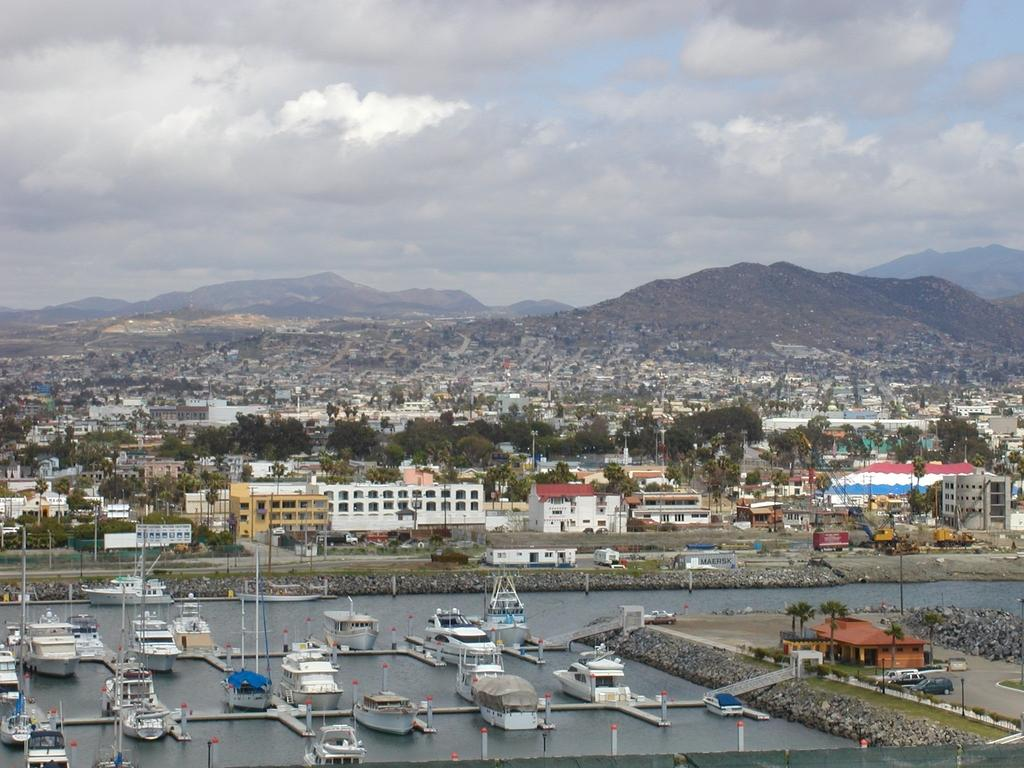What type of structures can be seen in the image? There are buildings in the image. What other natural elements are present in the image? There are trees and hills visible in the image. What can be seen in the water in the image? There are ships and boats in the water. How would you describe the sky in the image? The sky is blue and cloudy. Can you see the eyes of the bridge in the image? There is no bridge present in the image, so there are no eyes to see. How do the boats join the ships in the water? The boats do not join the ships in the image; they are separate entities in the water. 